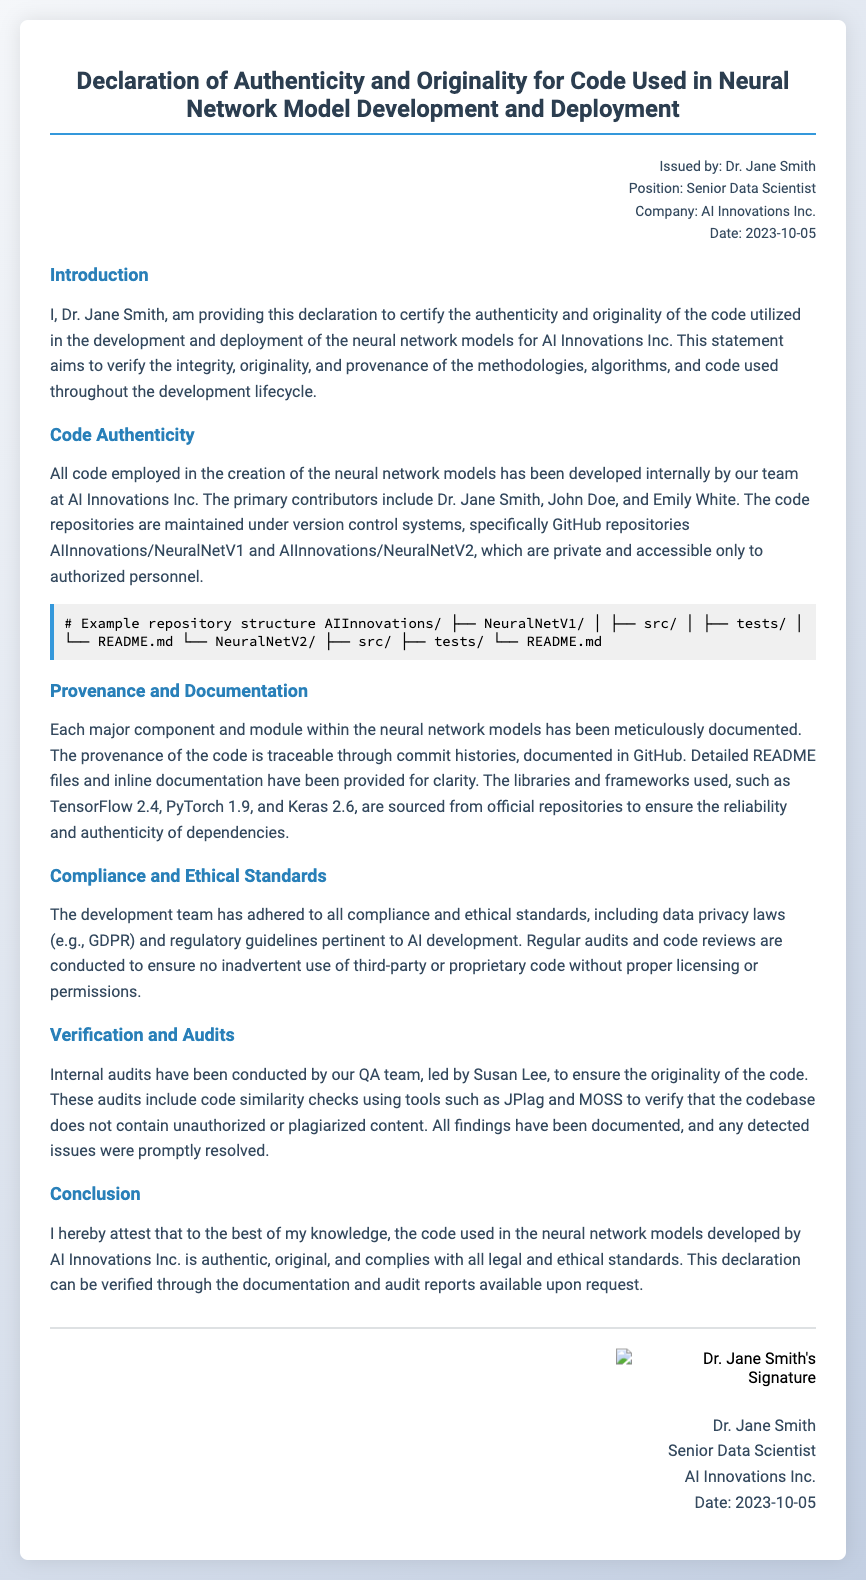What is the name of the issuer? The issuer of the declaration is clearly provided at the beginning of the document.
Answer: Dr. Jane Smith What is the position of the issuer? The document specifies the position of the issuer immediately after the name.
Answer: Senior Data Scientist What is the date of the declaration? The date is mentioned in the meta-info section of the document.
Answer: 2023-10-05 What frameworks are mentioned in the document? The document includes specific frameworks used in the development of neural network models.
Answer: TensorFlow 2.4, PyTorch 1.9, Keras 2.6 How many contributors are noted in the document? The document lists the names of the primary contributors to the code.
Answer: Three What tools are used for code similarity checks? The document highlights specific tools used to verify code originality.
Answer: JPlag and MOSS What is included within the signature block? The signature block includes personal and professional details about the issuer.
Answer: Dr. Jane Smith's signature What is the emphasis of the declaration? The declaration's purpose is highlighted in its introductory section.
Answer: Authenticity and originality 